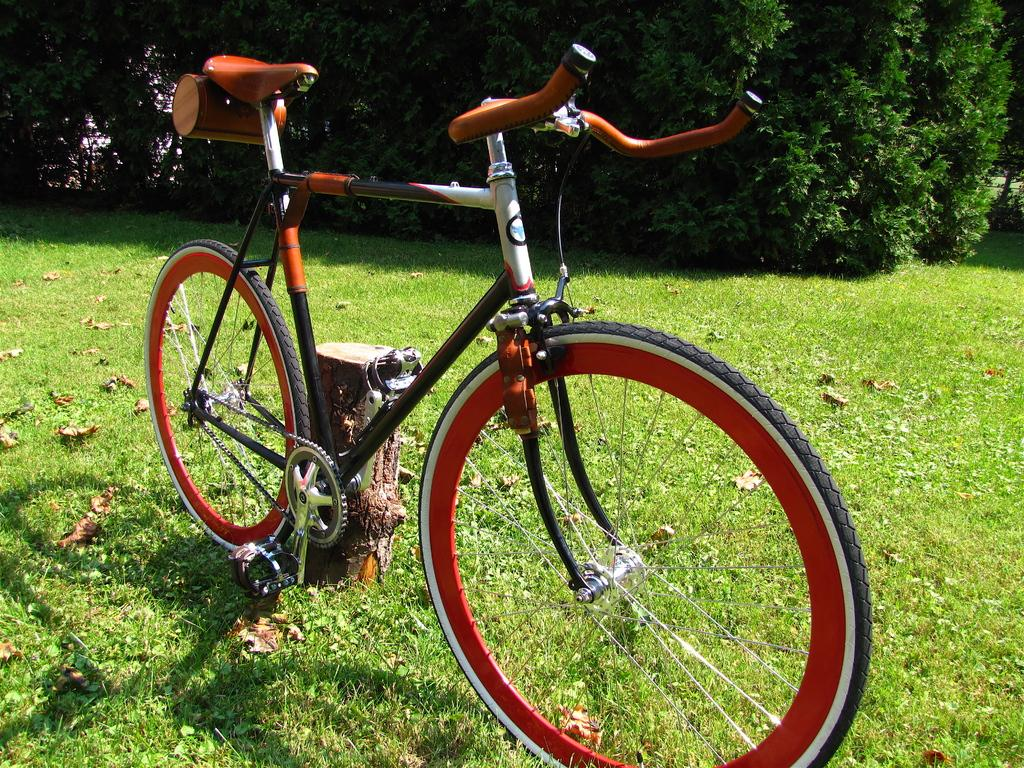What is the main object in the image? There is a bicycle in the image. Where is the bicycle located? The bicycle is parked on the grass. Is there any other object near the bicycle? Yes, the bicycle is near a wooden pole. What can be seen at the top of the image? There are plants visible at the top of the image. Can you tell me the color of the chess pieces on the wall in the image? There is no wall or chess pieces present in the image; it features a bicycle parked on the grass near a wooden pole, with plants visible at the top. 